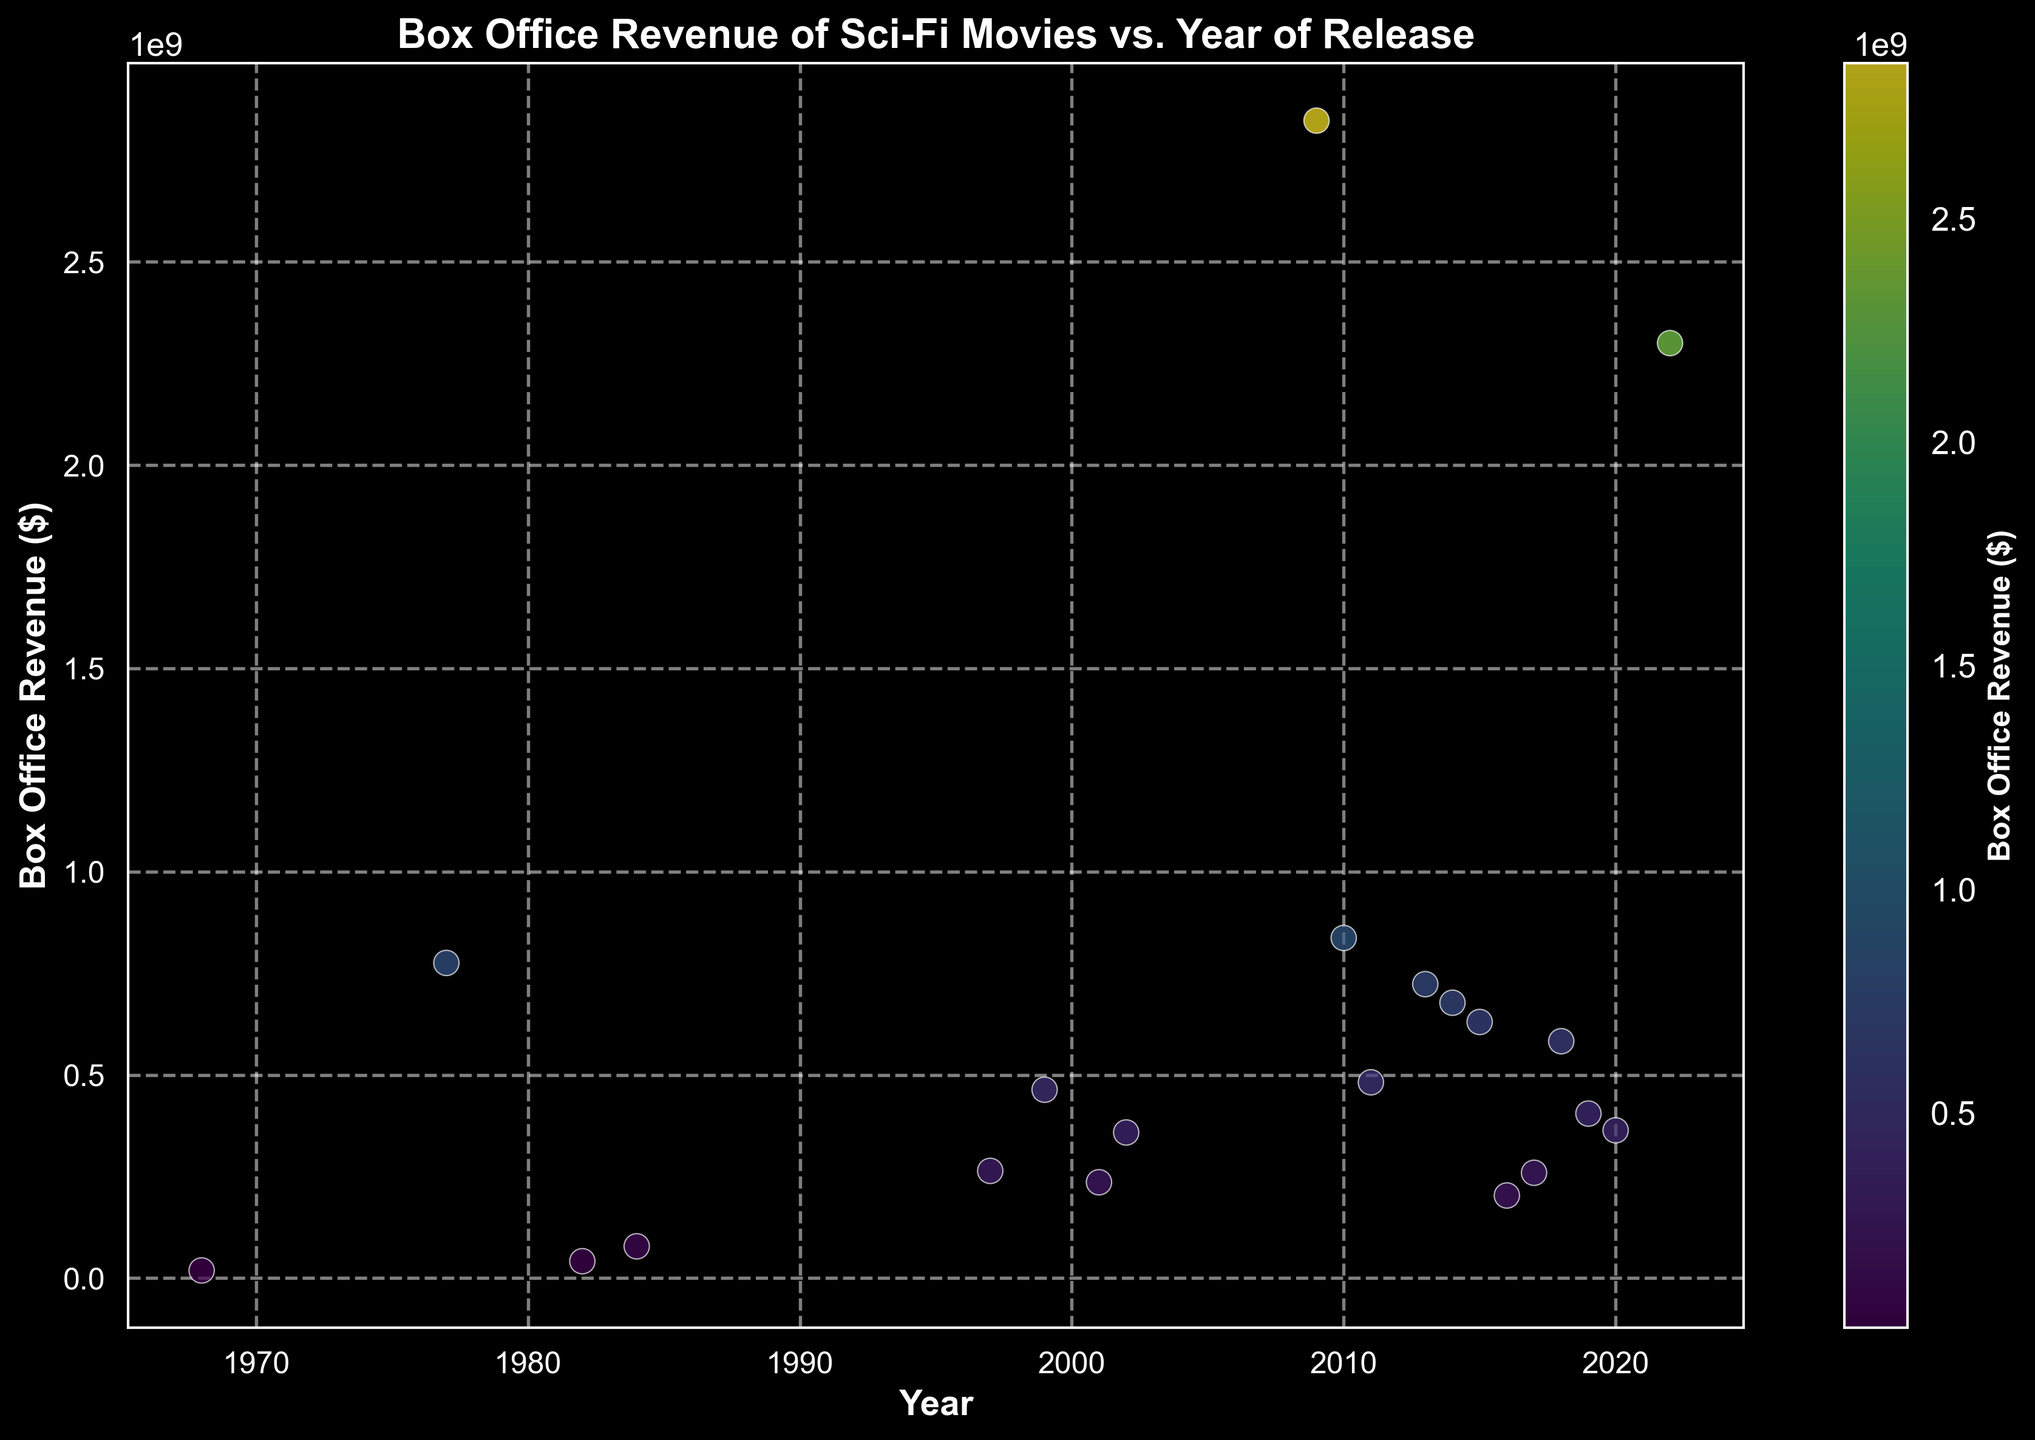Which movie had the highest box office revenue? By observing the scatter plot, locate the point highest on the y-axis. The title associated is "Avatar" from 2009.
Answer: Avatar How does the revenue of "2001: A Space Odyssey" compare to "Star Wars: Episode IV - A New Hope"? Locate the points for both movies in the plot. "2001: A Space Odyssey" has a lower y-axis position (revenue) compared to "Star Wars".
Answer: Star Wars: Episode IV - A New Hope is higher What is the trend of box office revenue for sci-fi movies over the years? Looking at the scatter plot, observe that the points generally trend upwards from left to right, indicating increasing revenue over time.
Answer: Increasing Which year had the most visually prominent cluster of high-revenue sci-fi movies? Examine the scatter plot for years with multiple points clustered high on the y-axis. 2014, 2015, and 2016 appear prominent.
Answer: 2014, 2015, 2016 What is the combined box office revenue of movies released in 2009 and 2010? Locate the points for 2009 and 2010; Avatar's revenue (2009) + Inception's revenue (2010) = 2847246203 + 836800000. Summing these gives 3684046203.
Answer: 3684046203 Which movie has the closest box office revenue to "The Matrix"? Find "The Matrix" point and look for the closest point in terms of vertical distance. "The Martian" is the closest.
Answer: The Martian How did the box office revenue of "Blade Runner 2049" compare to "Blade Runner" (1982)? Locate both points; "Blade Runner" (1982) had lower revenue compared to "Blade Runner 2049".
Answer: Blade Runner 2049 is higher Identify whether recent movies (post-2010) tend to have higher revenues compared to older releases. Compare the revenue of plotted points from years post-2010 plus their relative heights to those pre-2010. On average, post-2010 movies have higher revenues.
Answer: Yes, higher post-2010 Which movie released before the year 2000 had the highest box office revenue? Check the y-axis values for points from years before 2000. "Star Wars: Episode IV - A New Hope" is the highest.
Answer: Star Wars: Episode IV - A New Hope How does the box office revenue color scheme help distinguish movie revenues? The color gradient helps visually distinguish based on revenue, with greenish colors representing lower and yellowish colors representing higher.
Answer: Color gradient 